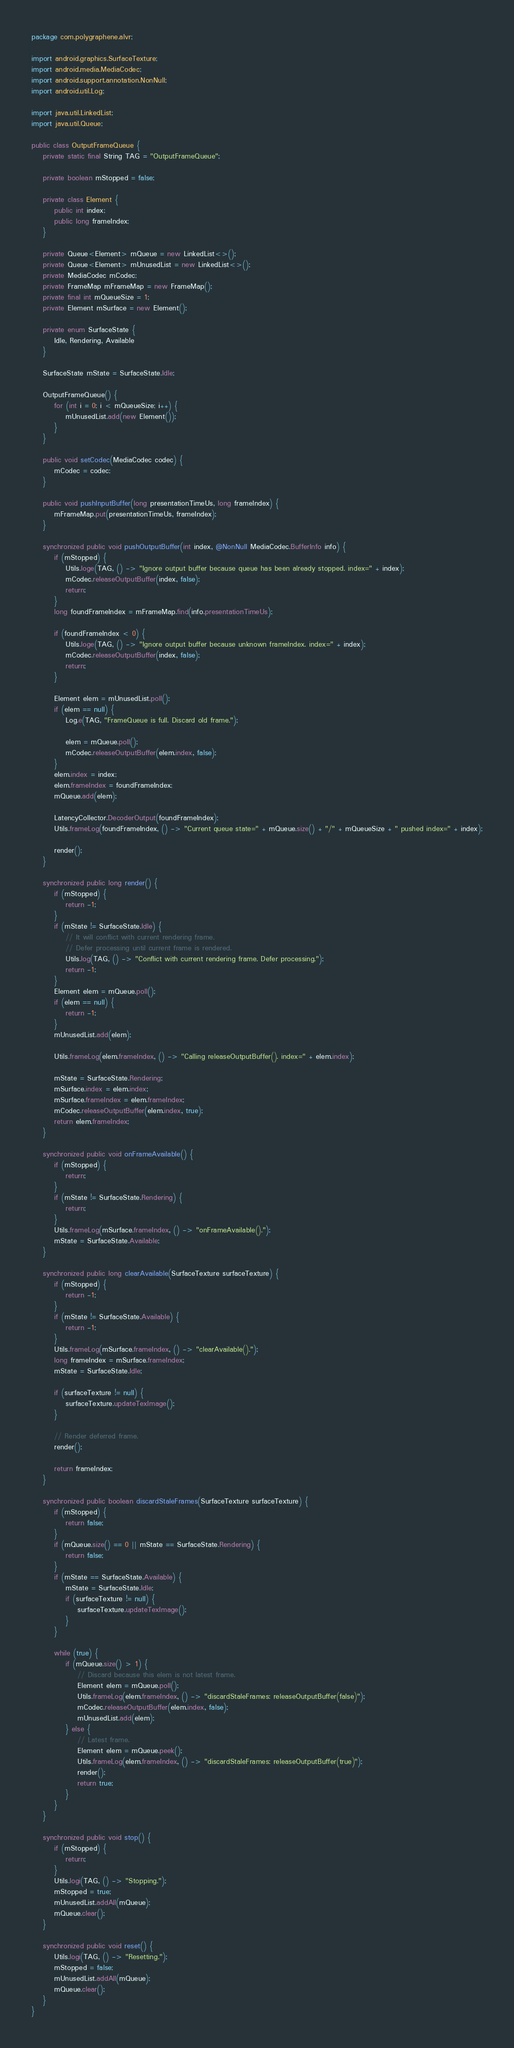Convert code to text. <code><loc_0><loc_0><loc_500><loc_500><_Java_>package com.polygraphene.alvr;

import android.graphics.SurfaceTexture;
import android.media.MediaCodec;
import android.support.annotation.NonNull;
import android.util.Log;

import java.util.LinkedList;
import java.util.Queue;

public class OutputFrameQueue {
    private static final String TAG = "OutputFrameQueue";

    private boolean mStopped = false;

    private class Element {
        public int index;
        public long frameIndex;
    }

    private Queue<Element> mQueue = new LinkedList<>();
    private Queue<Element> mUnusedList = new LinkedList<>();
    private MediaCodec mCodec;
    private FrameMap mFrameMap = new FrameMap();
    private final int mQueueSize = 1;
    private Element mSurface = new Element();

    private enum SurfaceState {
        Idle, Rendering, Available
    }

    SurfaceState mState = SurfaceState.Idle;

    OutputFrameQueue() {
        for (int i = 0; i < mQueueSize; i++) {
            mUnusedList.add(new Element());
        }
    }

    public void setCodec(MediaCodec codec) {
        mCodec = codec;
    }

    public void pushInputBuffer(long presentationTimeUs, long frameIndex) {
        mFrameMap.put(presentationTimeUs, frameIndex);
    }

    synchronized public void pushOutputBuffer(int index, @NonNull MediaCodec.BufferInfo info) {
        if (mStopped) {
            Utils.loge(TAG, () -> "Ignore output buffer because queue has been already stopped. index=" + index);
            mCodec.releaseOutputBuffer(index, false);
            return;
        }
        long foundFrameIndex = mFrameMap.find(info.presentationTimeUs);

        if (foundFrameIndex < 0) {
            Utils.loge(TAG, () -> "Ignore output buffer because unknown frameIndex. index=" + index);
            mCodec.releaseOutputBuffer(index, false);
            return;
        }

        Element elem = mUnusedList.poll();
        if (elem == null) {
            Log.e(TAG, "FrameQueue is full. Discard old frame.");

            elem = mQueue.poll();
            mCodec.releaseOutputBuffer(elem.index, false);
        }
        elem.index = index;
        elem.frameIndex = foundFrameIndex;
        mQueue.add(elem);

        LatencyCollector.DecoderOutput(foundFrameIndex);
        Utils.frameLog(foundFrameIndex, () -> "Current queue state=" + mQueue.size() + "/" + mQueueSize + " pushed index=" + index);

        render();
    }

    synchronized public long render() {
        if (mStopped) {
            return -1;
        }
        if (mState != SurfaceState.Idle) {
            // It will conflict with current rendering frame.
            // Defer processing until current frame is rendered.
            Utils.log(TAG, () -> "Conflict with current rendering frame. Defer processing.");
            return -1;
        }
        Element elem = mQueue.poll();
        if (elem == null) {
            return -1;
        }
        mUnusedList.add(elem);

        Utils.frameLog(elem.frameIndex, () -> "Calling releaseOutputBuffer(). index=" + elem.index);

        mState = SurfaceState.Rendering;
        mSurface.index = elem.index;
        mSurface.frameIndex = elem.frameIndex;
        mCodec.releaseOutputBuffer(elem.index, true);
        return elem.frameIndex;
    }

    synchronized public void onFrameAvailable() {
        if (mStopped) {
            return;
        }
        if (mState != SurfaceState.Rendering) {
            return;
        }
        Utils.frameLog(mSurface.frameIndex, () -> "onFrameAvailable().");
        mState = SurfaceState.Available;
    }

    synchronized public long clearAvailable(SurfaceTexture surfaceTexture) {
        if (mStopped) {
            return -1;
        }
        if (mState != SurfaceState.Available) {
            return -1;
        }
        Utils.frameLog(mSurface.frameIndex, () -> "clearAvailable().");
        long frameIndex = mSurface.frameIndex;
        mState = SurfaceState.Idle;

        if (surfaceTexture != null) {
            surfaceTexture.updateTexImage();
        }

        // Render deferred frame.
        render();

        return frameIndex;
    }

    synchronized public boolean discardStaleFrames(SurfaceTexture surfaceTexture) {
        if (mStopped) {
            return false;
        }
        if (mQueue.size() == 0 || mState == SurfaceState.Rendering) {
            return false;
        }
        if (mState == SurfaceState.Available) {
            mState = SurfaceState.Idle;
            if (surfaceTexture != null) {
                surfaceTexture.updateTexImage();
            }
        }

        while (true) {
            if (mQueue.size() > 1) {
                // Discard because this elem is not latest frame.
                Element elem = mQueue.poll();
                Utils.frameLog(elem.frameIndex, () -> "discardStaleFrames: releaseOutputBuffer(false)");
                mCodec.releaseOutputBuffer(elem.index, false);
                mUnusedList.add(elem);
            } else {
                // Latest frame.
                Element elem = mQueue.peek();
                Utils.frameLog(elem.frameIndex, () -> "discardStaleFrames: releaseOutputBuffer(true)");
                render();
                return true;
            }
        }
    }

    synchronized public void stop() {
        if (mStopped) {
            return;
        }
        Utils.logi(TAG, () -> "Stopping.");
        mStopped = true;
        mUnusedList.addAll(mQueue);
        mQueue.clear();
    }

    synchronized public void reset() {
        Utils.logi(TAG, () -> "Resetting.");
        mStopped = false;
        mUnusedList.addAll(mQueue);
        mQueue.clear();
    }
}
</code> 